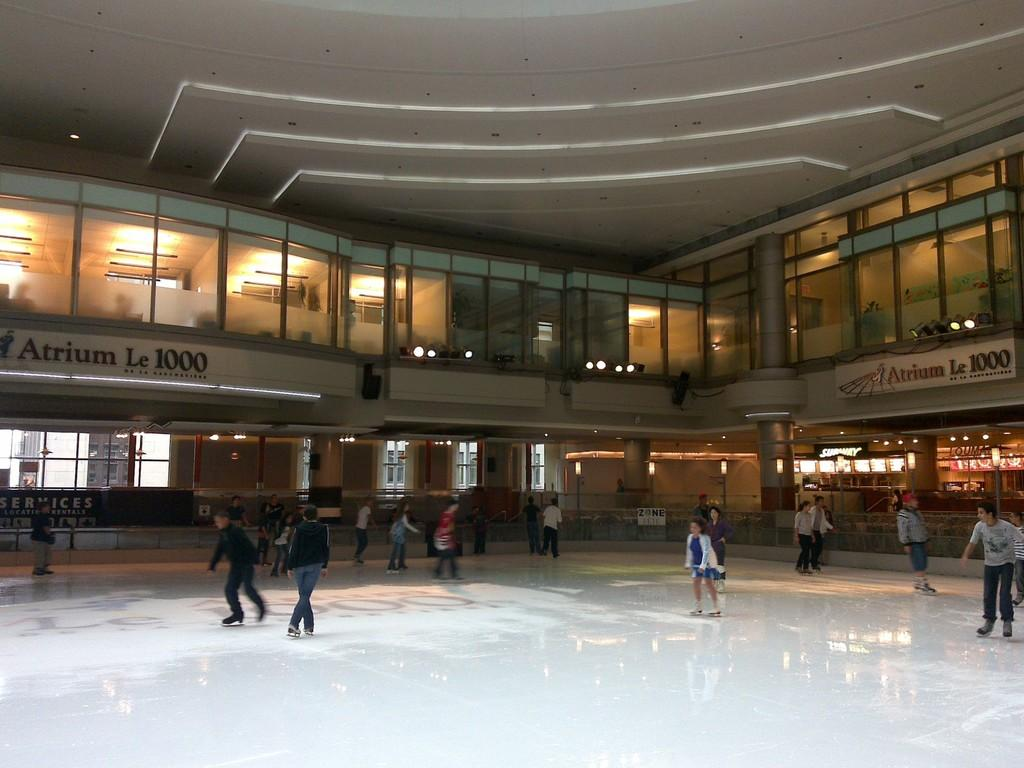What type of structure is visible in the image? There is a building in the image. What are some features of the building? The building has windows, pillars, lights, a name board, and a roof. What are the people in the image doing? The group of people is skating on the floor. What flavor of ice cream is being served to the governor in the image? There is no ice cream or governor present in the image. What is the head of the building made of in the image? The image does not provide information about the building's head or its construction material. 